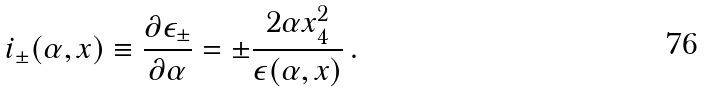Convert formula to latex. <formula><loc_0><loc_0><loc_500><loc_500>i _ { \pm } ( \alpha , { x } ) \equiv \frac { \partial \epsilon _ { \pm } } { \partial \alpha } = \pm \frac { 2 \alpha x _ { 4 } ^ { 2 } } { \epsilon ( \alpha , { x } ) } \, .</formula> 